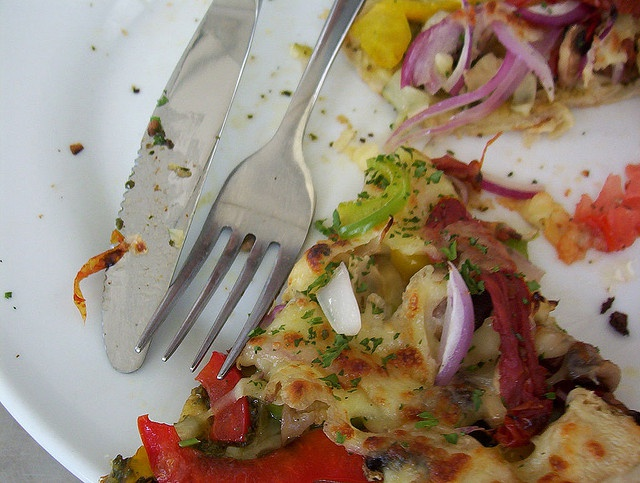Describe the objects in this image and their specific colors. I can see pizza in lightgray, maroon, olive, and tan tones, pizza in lightgray, gray, maroon, tan, and olive tones, knife in lightgray, darkgray, tan, gray, and olive tones, and fork in lightgray, darkgray, gray, and beige tones in this image. 